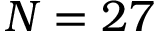<formula> <loc_0><loc_0><loc_500><loc_500>N = 2 7</formula> 